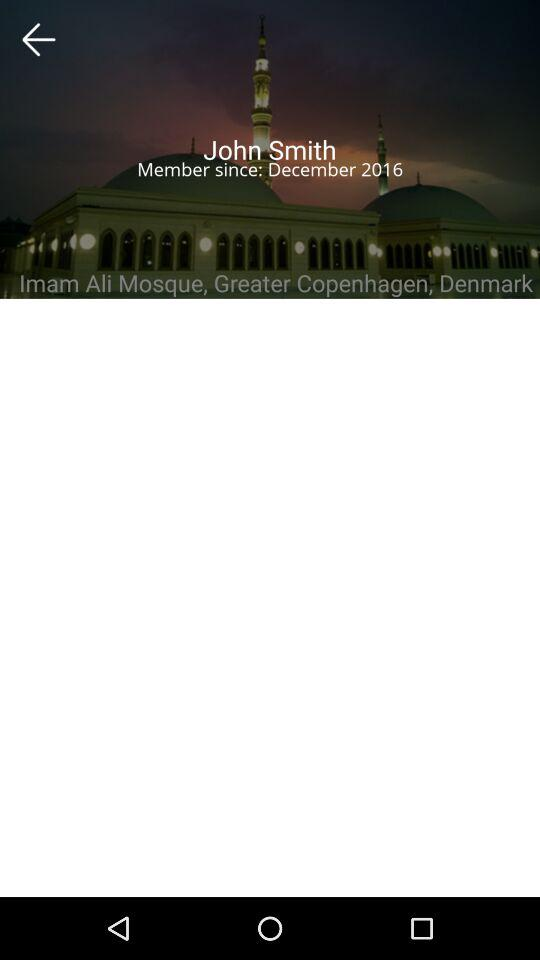When did John Smith become a member? John Smith has been a member since December 2016. 